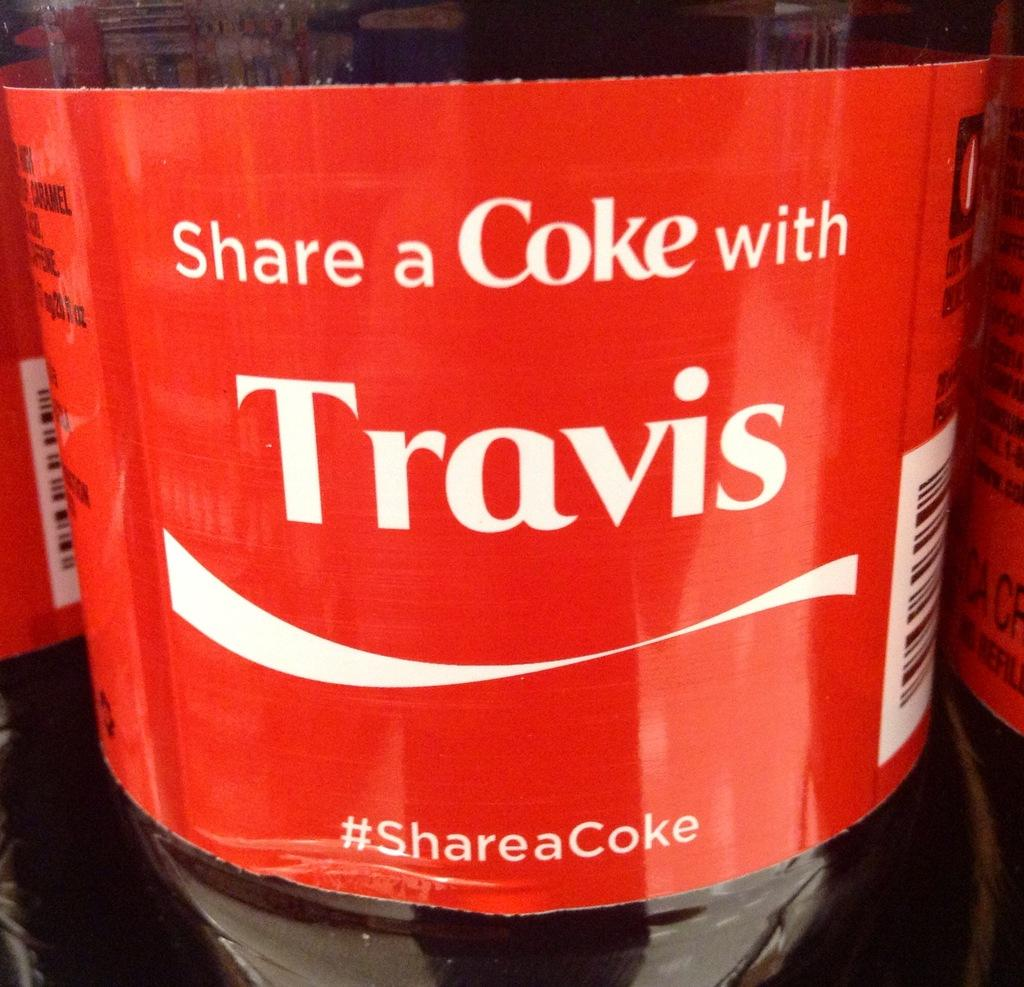Provide a one-sentence caption for the provided image. The label on a Coke bottle with a slogan that reads Share a Coke with Travis. 